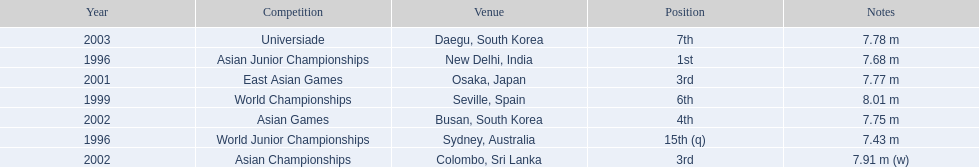Write the full table. {'header': ['Year', 'Competition', 'Venue', 'Position', 'Notes'], 'rows': [['2003', 'Universiade', 'Daegu, South Korea', '7th', '7.78 m'], ['1996', 'Asian Junior Championships', 'New Delhi, India', '1st', '7.68 m'], ['2001', 'East Asian Games', 'Osaka, Japan', '3rd', '7.77 m'], ['1999', 'World Championships', 'Seville, Spain', '6th', '8.01 m'], ['2002', 'Asian Games', 'Busan, South Korea', '4th', '7.75 m'], ['1996', 'World Junior Championships', 'Sydney, Australia', '15th (q)', '7.43 m'], ['2002', 'Asian Championships', 'Colombo, Sri Lanka', '3rd', '7.91 m (w)']]} Which year was his best jump? 1999. 